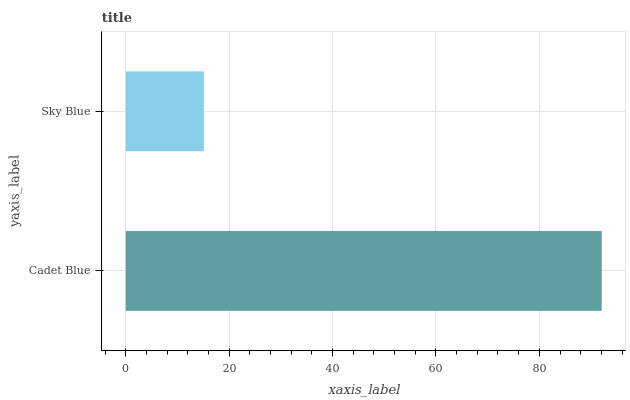Is Sky Blue the minimum?
Answer yes or no. Yes. Is Cadet Blue the maximum?
Answer yes or no. Yes. Is Sky Blue the maximum?
Answer yes or no. No. Is Cadet Blue greater than Sky Blue?
Answer yes or no. Yes. Is Sky Blue less than Cadet Blue?
Answer yes or no. Yes. Is Sky Blue greater than Cadet Blue?
Answer yes or no. No. Is Cadet Blue less than Sky Blue?
Answer yes or no. No. Is Cadet Blue the high median?
Answer yes or no. Yes. Is Sky Blue the low median?
Answer yes or no. Yes. Is Sky Blue the high median?
Answer yes or no. No. Is Cadet Blue the low median?
Answer yes or no. No. 